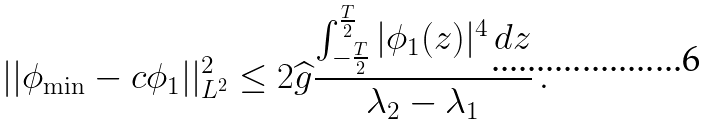<formula> <loc_0><loc_0><loc_500><loc_500>| | \phi _ { \min } - c \phi _ { 1 } | | ^ { 2 } _ { L ^ { 2 } } \leq 2 \widehat { g } \frac { \int _ { - \frac { T } { 2 } } ^ { \frac { T } { 2 } } | \phi _ { 1 } ( z ) | ^ { 4 } \, d z } { \lambda _ { 2 } - \lambda _ { 1 } } \, .</formula> 